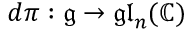<formula> <loc_0><loc_0><loc_500><loc_500>d \pi \colon { \mathfrak { g } } \to { \mathfrak { g l } } _ { n } ( \mathbb { C } )</formula> 